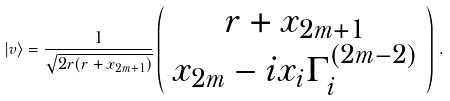<formula> <loc_0><loc_0><loc_500><loc_500>| v \rangle = { \frac { 1 } { \sqrt { 2 r ( r + x _ { 2 m + 1 } ) } } } \left ( \begin{array} { c } { { r + x _ { 2 m + 1 } } } \\ { { x _ { 2 m } - i x _ { i } \Gamma _ { i } ^ { ( 2 m - 2 ) } } } \end{array} \right ) \, .</formula> 